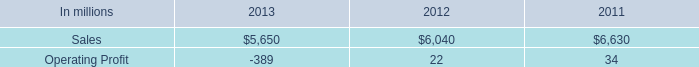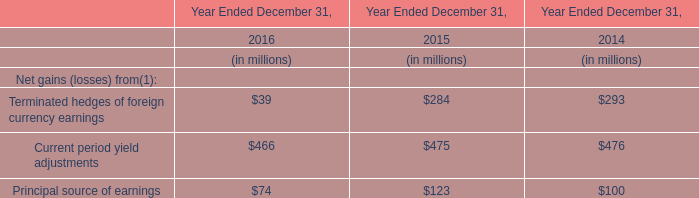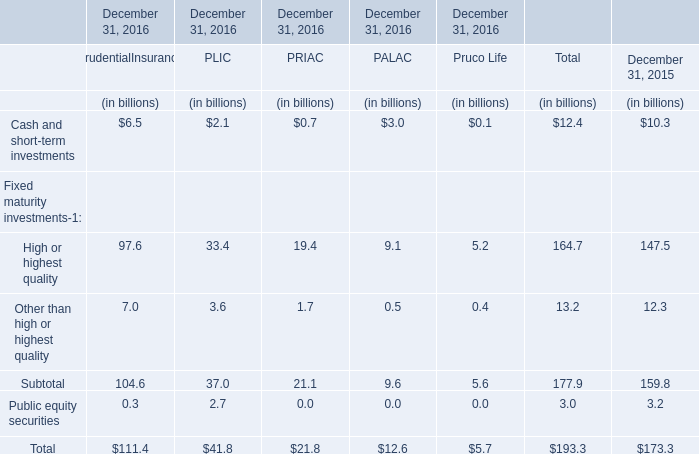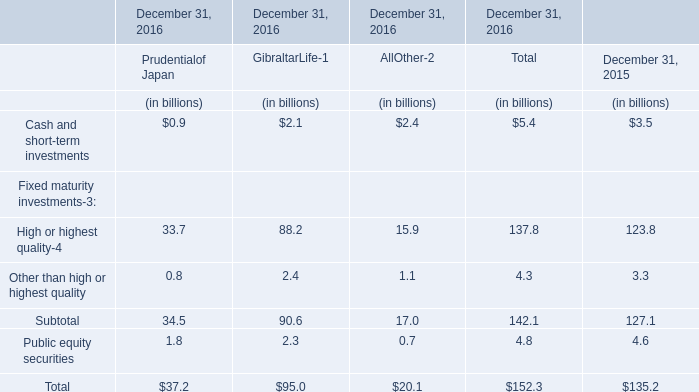At December 31, 2016,how much is the value of the Public equity securities for PLIC higher than the value of the Public equity securities for PALAC? (in billion) 
Computations: (2.7 - 0.0)
Answer: 2.7. 